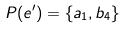<formula> <loc_0><loc_0><loc_500><loc_500>P ( e ^ { \prime } ) = \{ a _ { 1 } , b _ { 4 } \}</formula> 